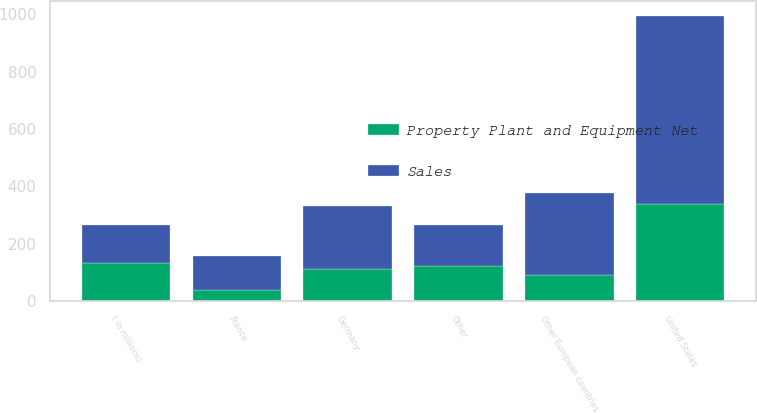Convert chart to OTSL. <chart><loc_0><loc_0><loc_500><loc_500><stacked_bar_chart><ecel><fcel>( in millions)<fcel>United States<fcel>Germany<fcel>France<fcel>Other European countries<fcel>Other<nl><fcel>Sales<fcel>133.45<fcel>655.5<fcel>219.4<fcel>118.2<fcel>285<fcel>143.3<nl><fcel>Property Plant and Equipment Net<fcel>133.45<fcel>339.4<fcel>110.9<fcel>40.4<fcel>91.5<fcel>123.6<nl></chart> 